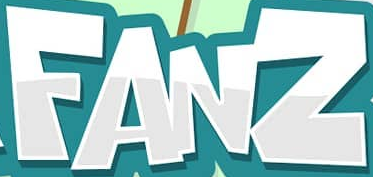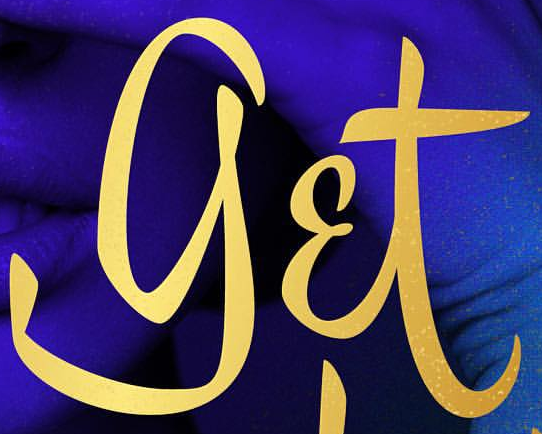What words are shown in these images in order, separated by a semicolon? FANZ; get 